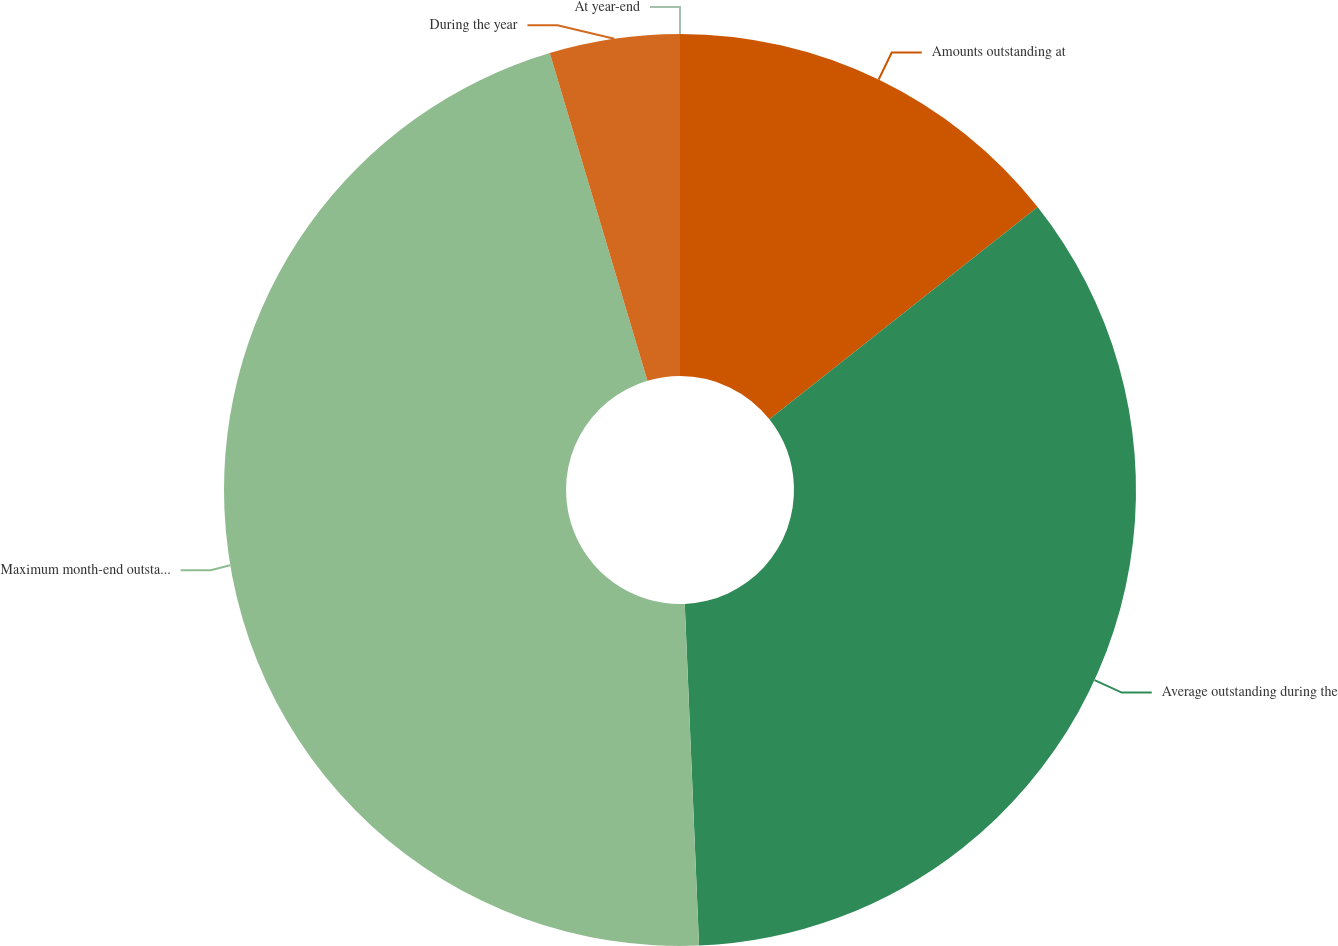Convert chart to OTSL. <chart><loc_0><loc_0><loc_500><loc_500><pie_chart><fcel>Amounts outstanding at<fcel>Average outstanding during the<fcel>Maximum month-end outstanding<fcel>During the year<fcel>At year-end<nl><fcel>14.35%<fcel>34.99%<fcel>46.06%<fcel>4.61%<fcel>0.0%<nl></chart> 